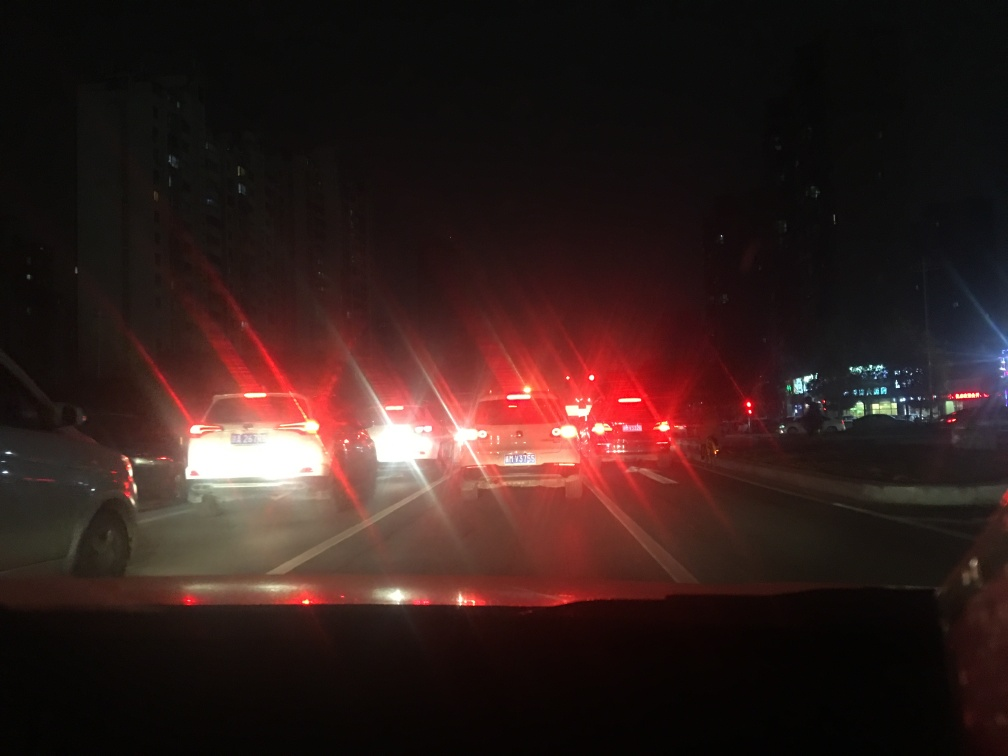Considering the glare from the lights, what advice would you offer to improve the quality of photos taken under similar conditions? To improve the quality of photos in low-light traffic conditions, one could use a camera with better low-light performance or manually adjust the camera settings to reduce glare. Lowering the ISO can minimize grain, and a slower shutter speed, if stabilizing the camera is possible, could help to capture more light without the glare. Additionally, using a lens hood may reduce lens flare from the strong vehicle lights. For smartphone cameras, utilizing night mode or a third-party camera app with more advanced controls can yield better results. 